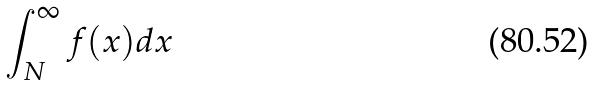<formula> <loc_0><loc_0><loc_500><loc_500>\int _ { N } ^ { \infty } f ( x ) d x</formula> 